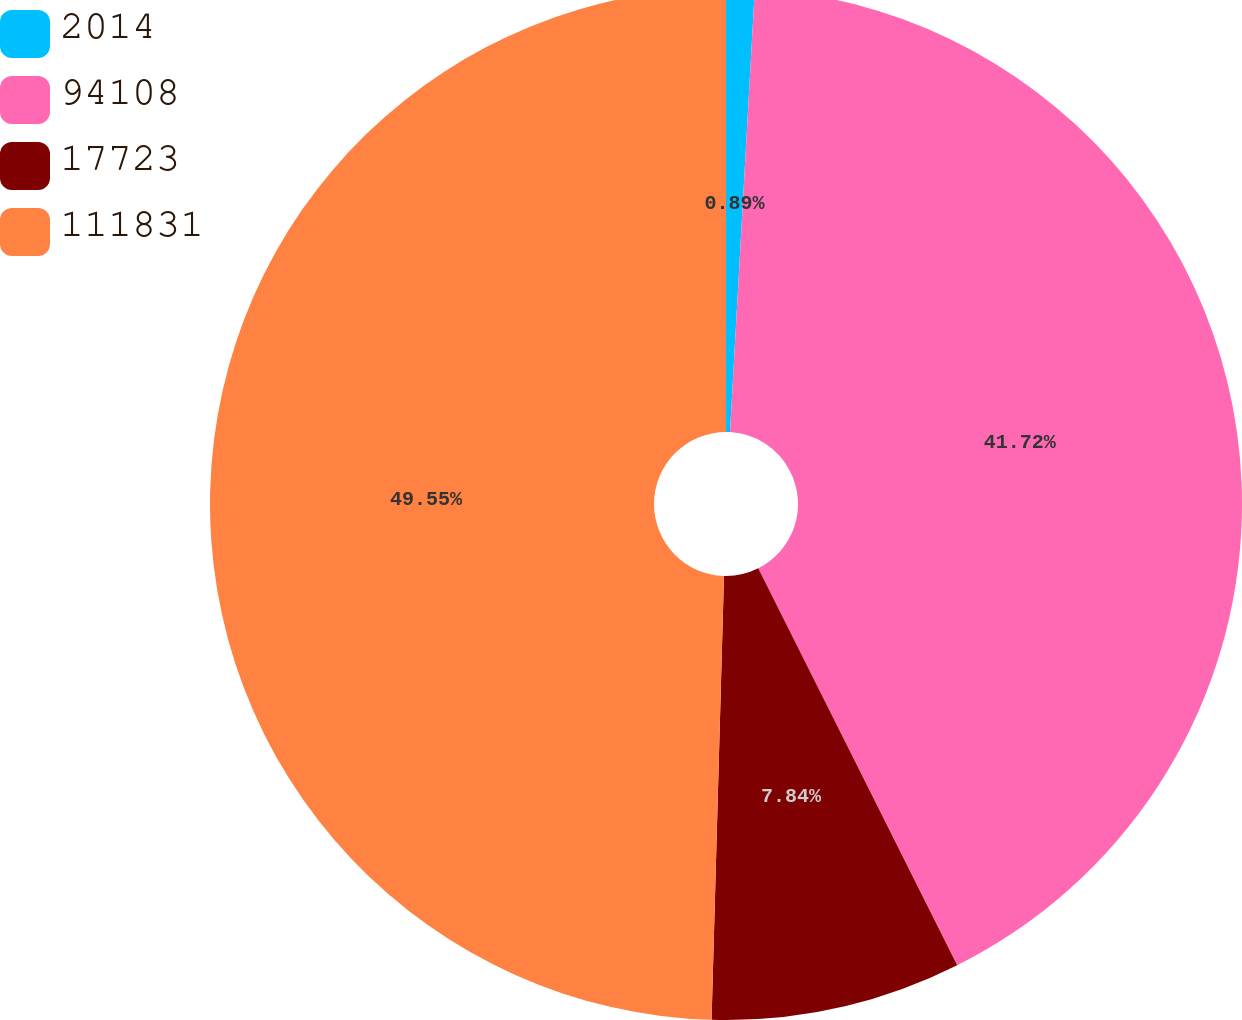Convert chart to OTSL. <chart><loc_0><loc_0><loc_500><loc_500><pie_chart><fcel>2014<fcel>94108<fcel>17723<fcel>111831<nl><fcel>0.89%<fcel>41.72%<fcel>7.84%<fcel>49.56%<nl></chart> 